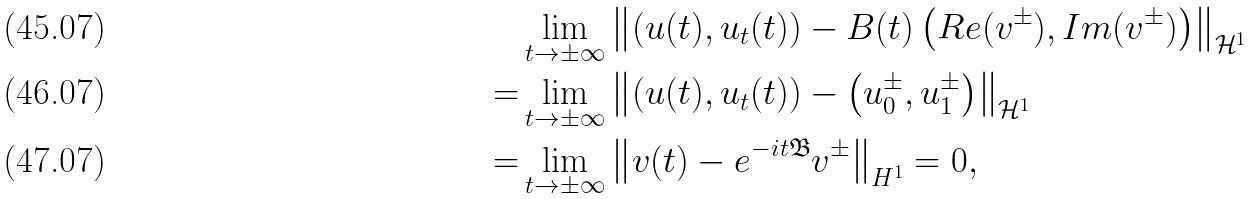Convert formula to latex. <formula><loc_0><loc_0><loc_500><loc_500>& \lim _ { t \rightarrow \pm \infty } \left \| \left ( u ( t ) , u _ { t } ( t ) \right ) - B ( t ) \left ( R e ( v ^ { \pm } ) , I m ( v ^ { \pm } ) \right ) \right \| _ { \mathcal { H } ^ { 1 } } \\ = & \lim _ { t \rightarrow \pm \infty } \left \| \left ( u ( t ) , u _ { t } ( t ) \right ) - \left ( u _ { 0 } ^ { \pm } , u _ { 1 } ^ { \pm } \right ) \right \| _ { \mathcal { H } ^ { 1 } } \\ = & \lim _ { t \rightarrow \pm \infty } \left \| v ( t ) - e ^ { - i t \mathfrak { B } } v ^ { \pm } \right \| _ { H ^ { 1 } } = 0 ,</formula> 